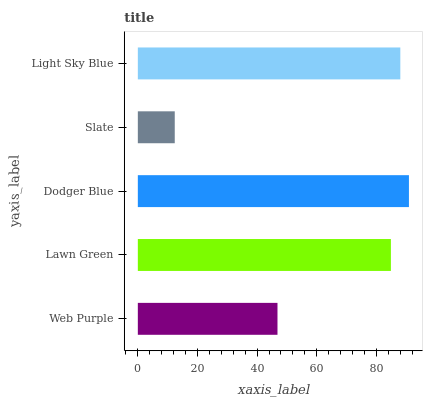Is Slate the minimum?
Answer yes or no. Yes. Is Dodger Blue the maximum?
Answer yes or no. Yes. Is Lawn Green the minimum?
Answer yes or no. No. Is Lawn Green the maximum?
Answer yes or no. No. Is Lawn Green greater than Web Purple?
Answer yes or no. Yes. Is Web Purple less than Lawn Green?
Answer yes or no. Yes. Is Web Purple greater than Lawn Green?
Answer yes or no. No. Is Lawn Green less than Web Purple?
Answer yes or no. No. Is Lawn Green the high median?
Answer yes or no. Yes. Is Lawn Green the low median?
Answer yes or no. Yes. Is Web Purple the high median?
Answer yes or no. No. Is Slate the low median?
Answer yes or no. No. 